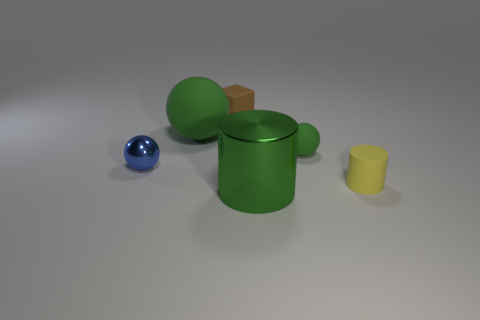Subtract all green matte spheres. How many spheres are left? 1 Add 1 small brown rubber blocks. How many objects exist? 7 Subtract all blocks. How many objects are left? 5 Subtract all green cylinders. How many cylinders are left? 1 Subtract 1 blocks. How many blocks are left? 0 Add 4 matte cubes. How many matte cubes are left? 5 Add 2 green shiny cylinders. How many green shiny cylinders exist? 3 Subtract 1 green cylinders. How many objects are left? 5 Subtract all brown spheres. Subtract all cyan blocks. How many spheres are left? 3 Subtract all red balls. How many green cylinders are left? 1 